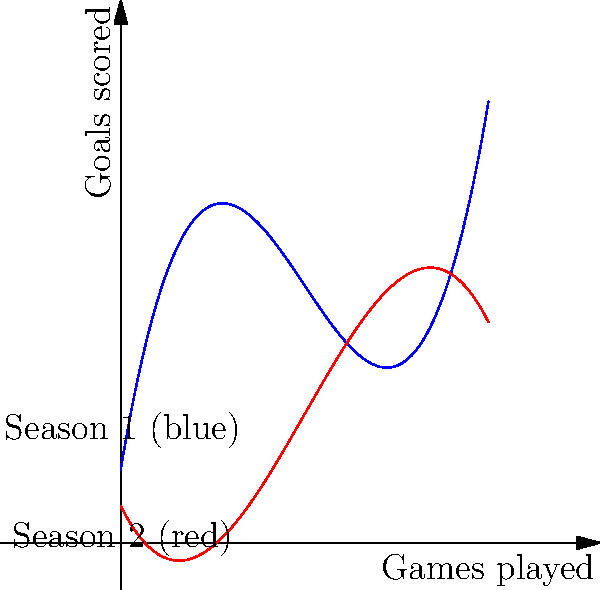The graph shows Vertz's goal-scoring patterns over two seasons. The blue curve represents Season 1, given by $f(x) = 0.1x^3 - 1.5x^2 + 6x + 2$, and the red curve represents Season 2, given by $g(x) = -0.05x^3 + 0.75x^2 - 2x + 1$, where $x$ is the number of games played. Calculate the difference in total goals scored between the two seasons over the first 10 games. To find the difference in total goals scored, we need to:

1. Calculate the area under each curve from $x=0$ to $x=10$.
2. Subtract the area of Season 2 from Season 1.

For Season 1:
$$\int_0^{10} f(x) dx = \int_0^{10} (0.1x^3 - 1.5x^2 + 6x + 2) dx$$
$$= [0.025x^4 - 0.5x^3 + 3x^2 + 2x]_0^{10}$$
$$= (250 - 500 + 300 + 20) - (0 - 0 + 0 + 0) = 70$$

For Season 2:
$$\int_0^{10} g(x) dx = \int_0^{10} (-0.05x^3 + 0.75x^2 - 2x + 1) dx$$
$$= [-0.0125x^4 + 0.25x^3 - x^2 + x]_0^{10}$$
$$= (-125 + 250 - 100 + 10) - (0 + 0 - 0 + 0) = 35$$

The difference in total goals:
$$70 - 35 = 35$$

Therefore, Vertz scored 35 more goals in Season 1 compared to Season 2 over the first 10 games.
Answer: 35 goals 